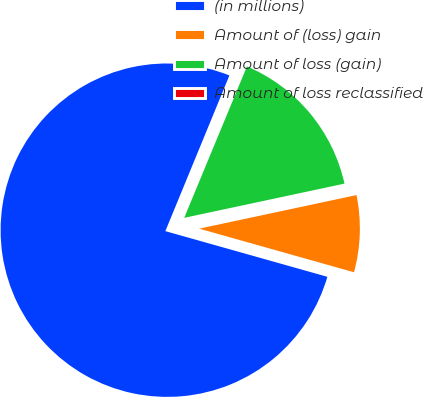Convert chart to OTSL. <chart><loc_0><loc_0><loc_500><loc_500><pie_chart><fcel>(in millions)<fcel>Amount of (loss) gain<fcel>Amount of loss (gain)<fcel>Amount of loss reclassified<nl><fcel>76.84%<fcel>7.72%<fcel>15.4%<fcel>0.04%<nl></chart> 